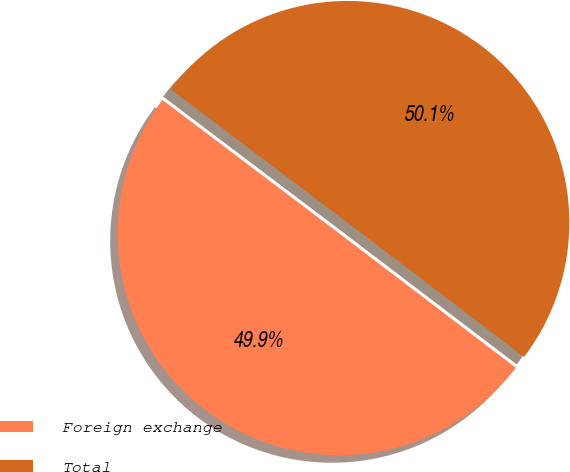Convert chart to OTSL. <chart><loc_0><loc_0><loc_500><loc_500><pie_chart><fcel>Foreign exchange<fcel>Total<nl><fcel>49.94%<fcel>50.06%<nl></chart> 